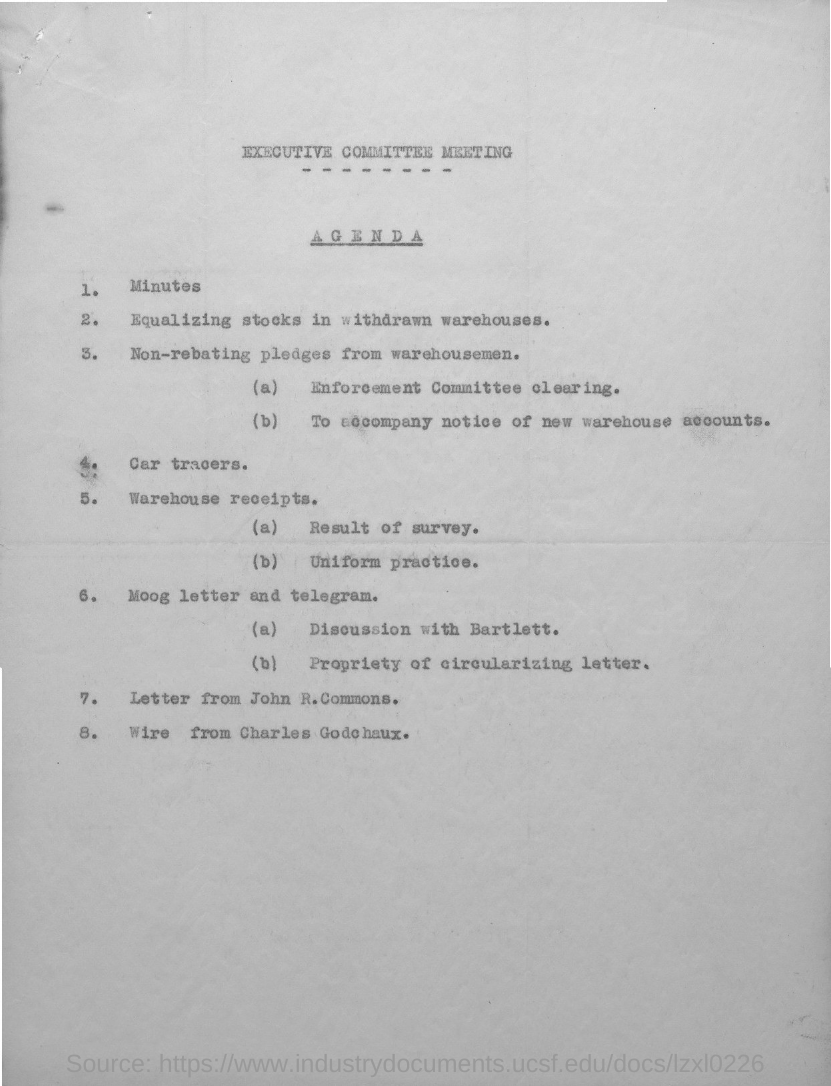What is the first title in the document?
Your answer should be very brief. Executive Committee Meeting. What is the second title in the document?
Provide a short and direct response. Agenda. What is agenda number 1?
Your answer should be compact. Minutes. What is agenda number 4?
Keep it short and to the point. Car tracers. What is agenda number 7?
Offer a terse response. Letter from john r.commons. 